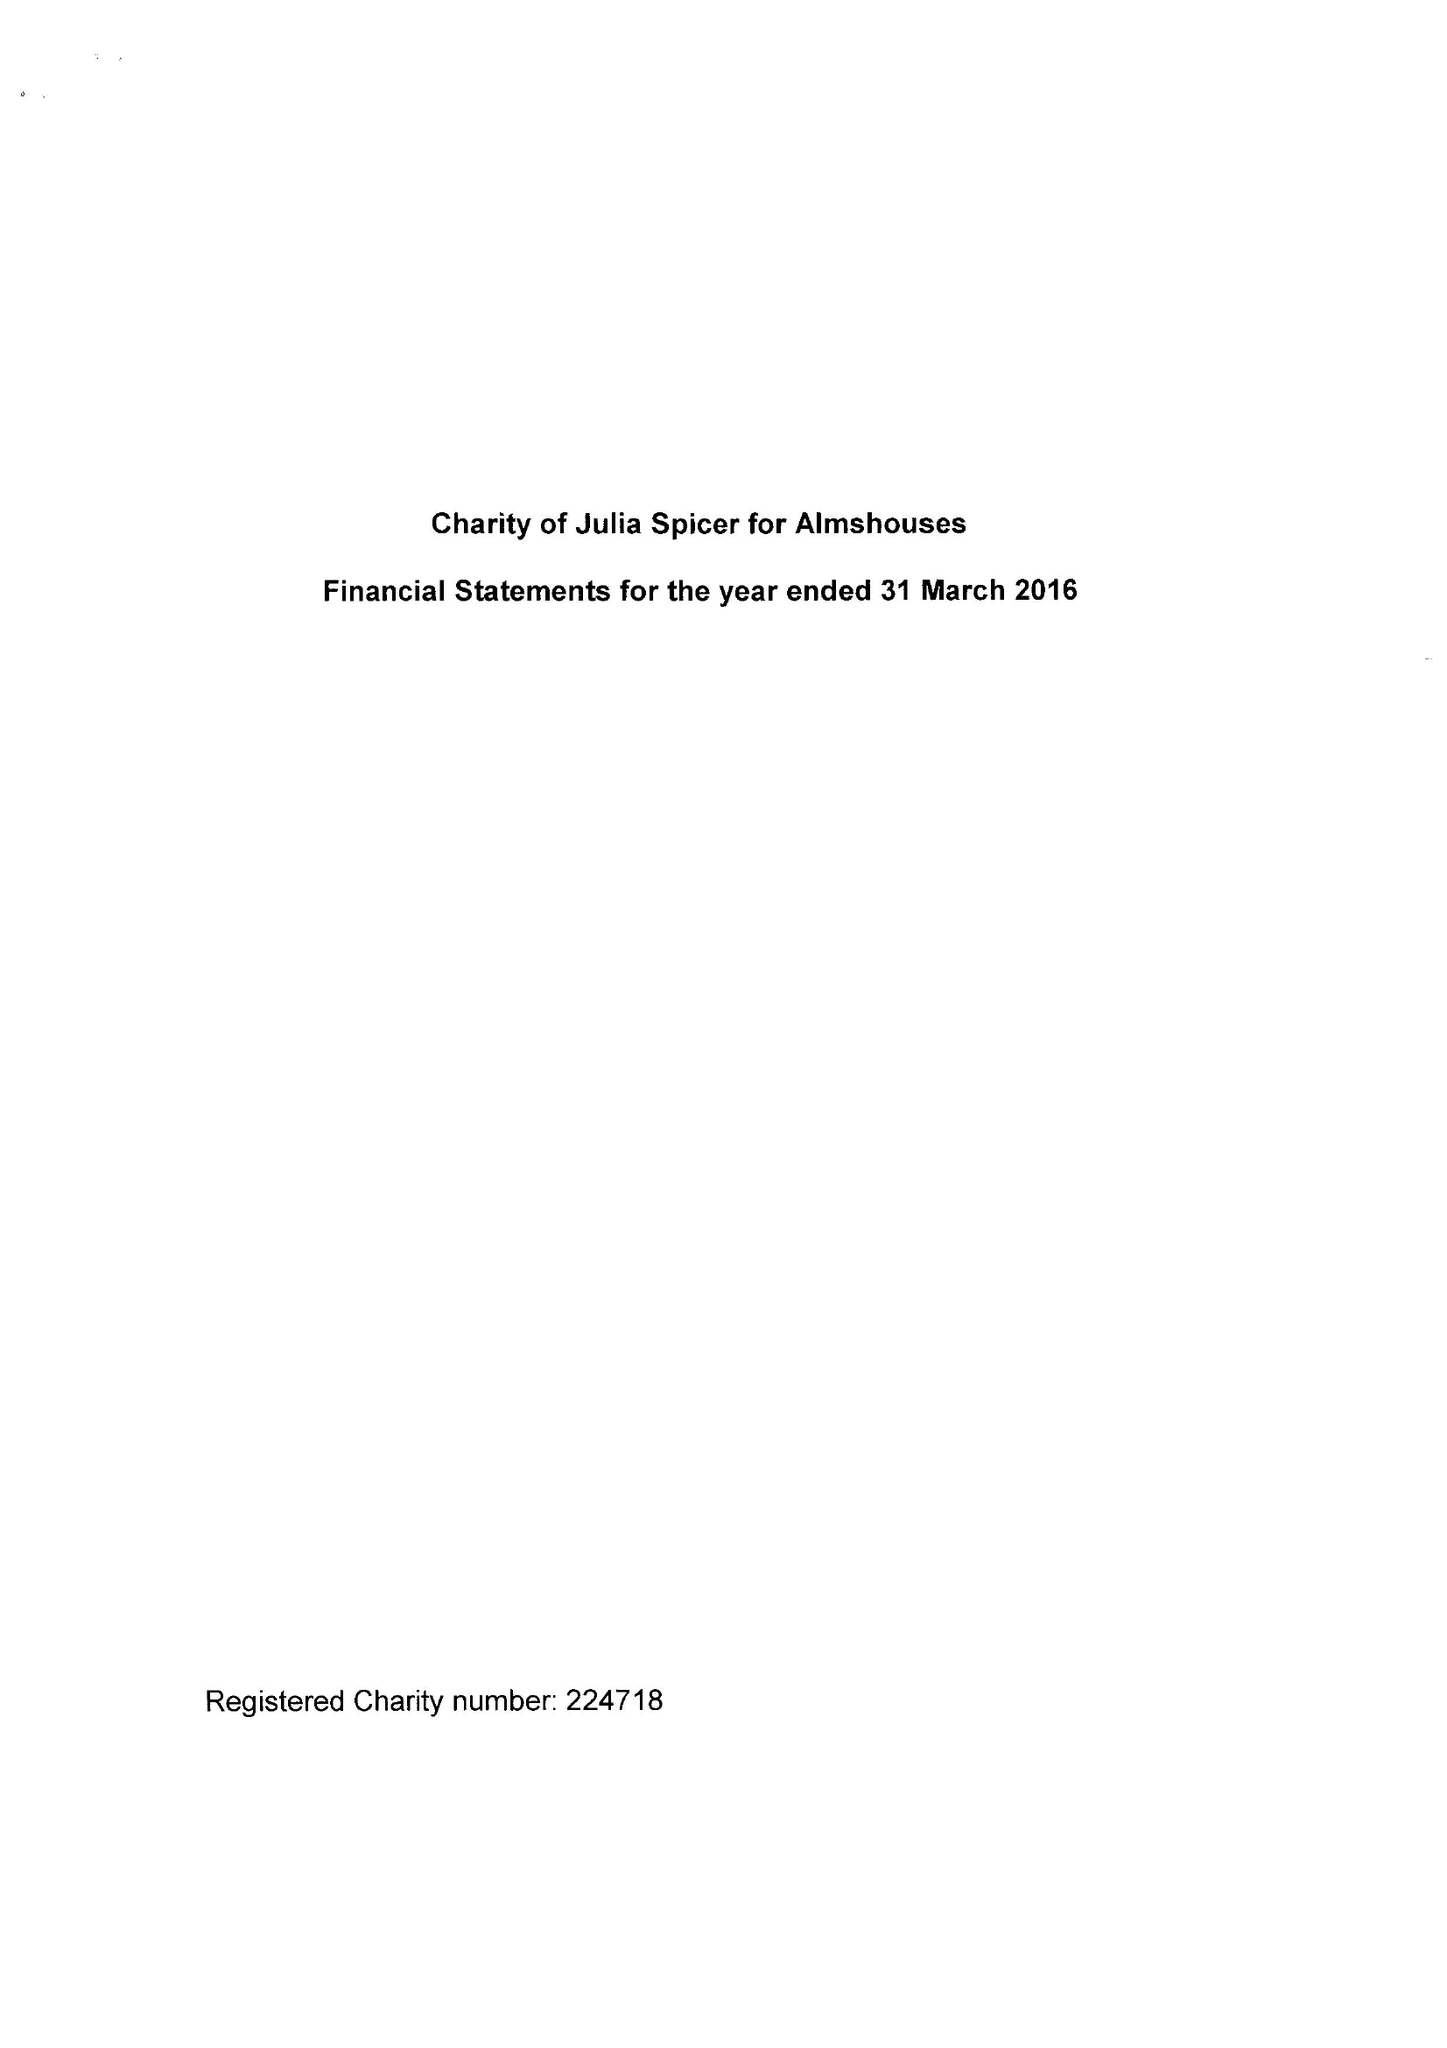What is the value for the address__post_town?
Answer the question using a single word or phrase. CROYDON 